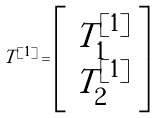Convert formula to latex. <formula><loc_0><loc_0><loc_500><loc_500>T ^ { [ 1 ] } = \left [ \begin{array} { c } T ^ { [ 1 ] } _ { 1 } \\ T ^ { [ 1 ] } _ { 2 } \end{array} \right ]</formula> 